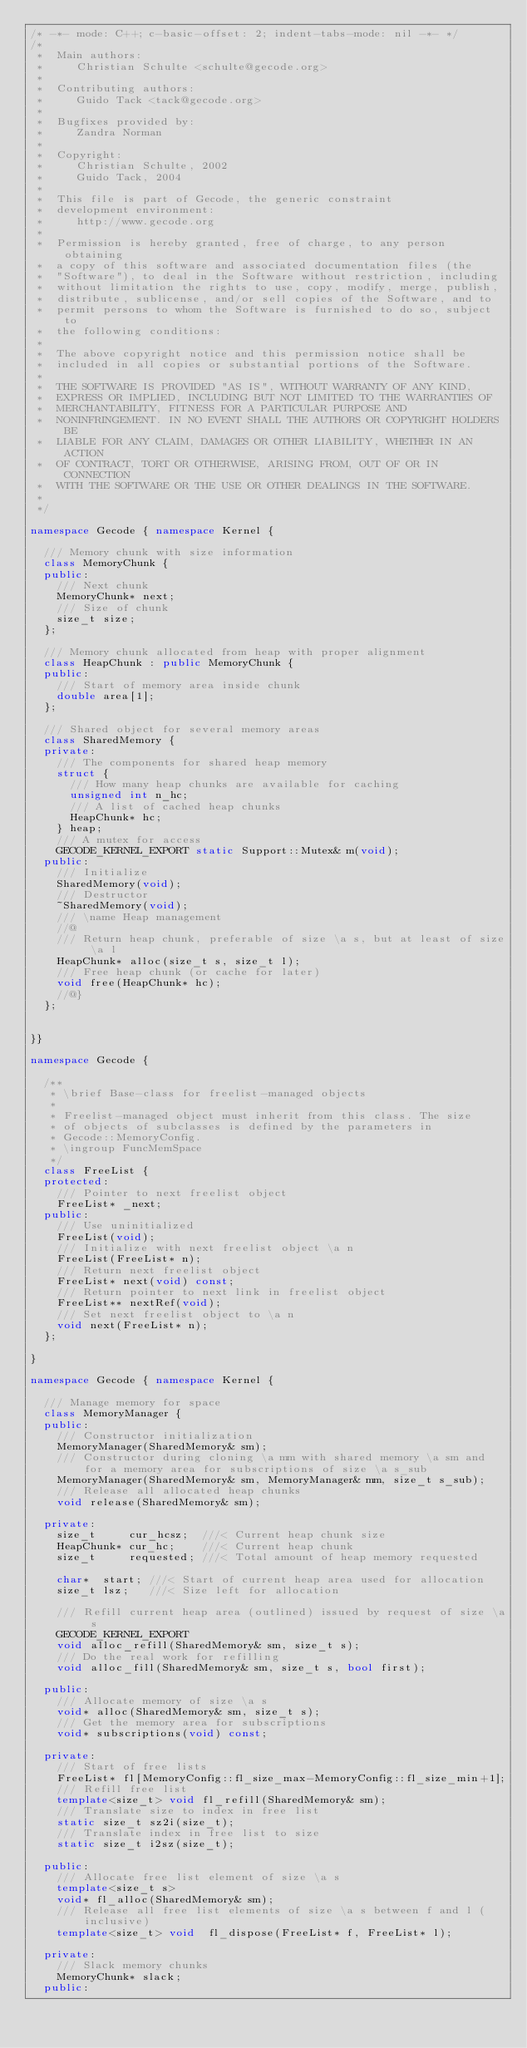Convert code to text. <code><loc_0><loc_0><loc_500><loc_500><_C++_>/* -*- mode: C++; c-basic-offset: 2; indent-tabs-mode: nil -*- */
/*
 *  Main authors:
 *     Christian Schulte <schulte@gecode.org>
 *
 *  Contributing authors:
 *     Guido Tack <tack@gecode.org>
 *
 *  Bugfixes provided by:
 *     Zandra Norman
 *
 *  Copyright:
 *     Christian Schulte, 2002
 *     Guido Tack, 2004
 *
 *  This file is part of Gecode, the generic constraint
 *  development environment:
 *     http://www.gecode.org
 *
 *  Permission is hereby granted, free of charge, to any person obtaining
 *  a copy of this software and associated documentation files (the
 *  "Software"), to deal in the Software without restriction, including
 *  without limitation the rights to use, copy, modify, merge, publish,
 *  distribute, sublicense, and/or sell copies of the Software, and to
 *  permit persons to whom the Software is furnished to do so, subject to
 *  the following conditions:
 *
 *  The above copyright notice and this permission notice shall be
 *  included in all copies or substantial portions of the Software.
 *
 *  THE SOFTWARE IS PROVIDED "AS IS", WITHOUT WARRANTY OF ANY KIND,
 *  EXPRESS OR IMPLIED, INCLUDING BUT NOT LIMITED TO THE WARRANTIES OF
 *  MERCHANTABILITY, FITNESS FOR A PARTICULAR PURPOSE AND
 *  NONINFRINGEMENT. IN NO EVENT SHALL THE AUTHORS OR COPYRIGHT HOLDERS BE
 *  LIABLE FOR ANY CLAIM, DAMAGES OR OTHER LIABILITY, WHETHER IN AN ACTION
 *  OF CONTRACT, TORT OR OTHERWISE, ARISING FROM, OUT OF OR IN CONNECTION
 *  WITH THE SOFTWARE OR THE USE OR OTHER DEALINGS IN THE SOFTWARE.
 *
 */

namespace Gecode { namespace Kernel {

  /// Memory chunk with size information
  class MemoryChunk {
  public:
    /// Next chunk
    MemoryChunk* next;
    /// Size of chunk
    size_t size;
  };

  /// Memory chunk allocated from heap with proper alignment
  class HeapChunk : public MemoryChunk {
  public:
    /// Start of memory area inside chunk
    double area[1];
  };

  /// Shared object for several memory areas
  class SharedMemory {
  private:
    /// The components for shared heap memory
    struct {
      /// How many heap chunks are available for caching
      unsigned int n_hc;
      /// A list of cached heap chunks
      HeapChunk* hc;
    } heap;
    /// A mutex for access
    GECODE_KERNEL_EXPORT static Support::Mutex& m(void);
  public:
    /// Initialize
    SharedMemory(void);
    /// Destructor
    ~SharedMemory(void);
    /// \name Heap management
    //@
    /// Return heap chunk, preferable of size \a s, but at least of size \a l
    HeapChunk* alloc(size_t s, size_t l);
    /// Free heap chunk (or cache for later)
    void free(HeapChunk* hc);
    //@}
  };


}}

namespace Gecode {

  /**
   * \brief Base-class for freelist-managed objects
   *
   * Freelist-managed object must inherit from this class. The size
   * of objects of subclasses is defined by the parameters in
   * Gecode::MemoryConfig.
   * \ingroup FuncMemSpace
   */
  class FreeList {
  protected:
    /// Pointer to next freelist object
    FreeList* _next;
  public:
    /// Use uninitialized
    FreeList(void);
    /// Initialize with next freelist object \a n
    FreeList(FreeList* n);
    /// Return next freelist object
    FreeList* next(void) const;
    /// Return pointer to next link in freelist object
    FreeList** nextRef(void);
    /// Set next freelist object to \a n
    void next(FreeList* n);
  };

}

namespace Gecode { namespace Kernel {

  /// Manage memory for space
  class MemoryManager {
  public:
    /// Constructor initialization
    MemoryManager(SharedMemory& sm);
    /// Constructor during cloning \a mm with shared memory \a sm and for a memory area for subscriptions of size \a s_sub
    MemoryManager(SharedMemory& sm, MemoryManager& mm, size_t s_sub);
    /// Release all allocated heap chunks
    void release(SharedMemory& sm);

  private:
    size_t     cur_hcsz;  ///< Current heap chunk size
    HeapChunk* cur_hc;    ///< Current heap chunk
    size_t     requested; ///< Total amount of heap memory requested

    char*  start; ///< Start of current heap area used for allocation
    size_t lsz;   ///< Size left for allocation

    /// Refill current heap area (outlined) issued by request of size \a s
    GECODE_KERNEL_EXPORT
    void alloc_refill(SharedMemory& sm, size_t s);
    /// Do the real work for refilling
    void alloc_fill(SharedMemory& sm, size_t s, bool first);

  public:
    /// Allocate memory of size \a s
    void* alloc(SharedMemory& sm, size_t s);
    /// Get the memory area for subscriptions
    void* subscriptions(void) const;

  private:
    /// Start of free lists
    FreeList* fl[MemoryConfig::fl_size_max-MemoryConfig::fl_size_min+1];
    /// Refill free list
    template<size_t> void fl_refill(SharedMemory& sm);
    /// Translate size to index in free list
    static size_t sz2i(size_t);
    /// Translate index in free list to size
    static size_t i2sz(size_t);

  public:
    /// Allocate free list element of size \a s
    template<size_t s>
    void* fl_alloc(SharedMemory& sm);
    /// Release all free list elements of size \a s between f and l (inclusive)
    template<size_t> void  fl_dispose(FreeList* f, FreeList* l);

  private:
    /// Slack memory chunks
    MemoryChunk* slack;
  public:</code> 